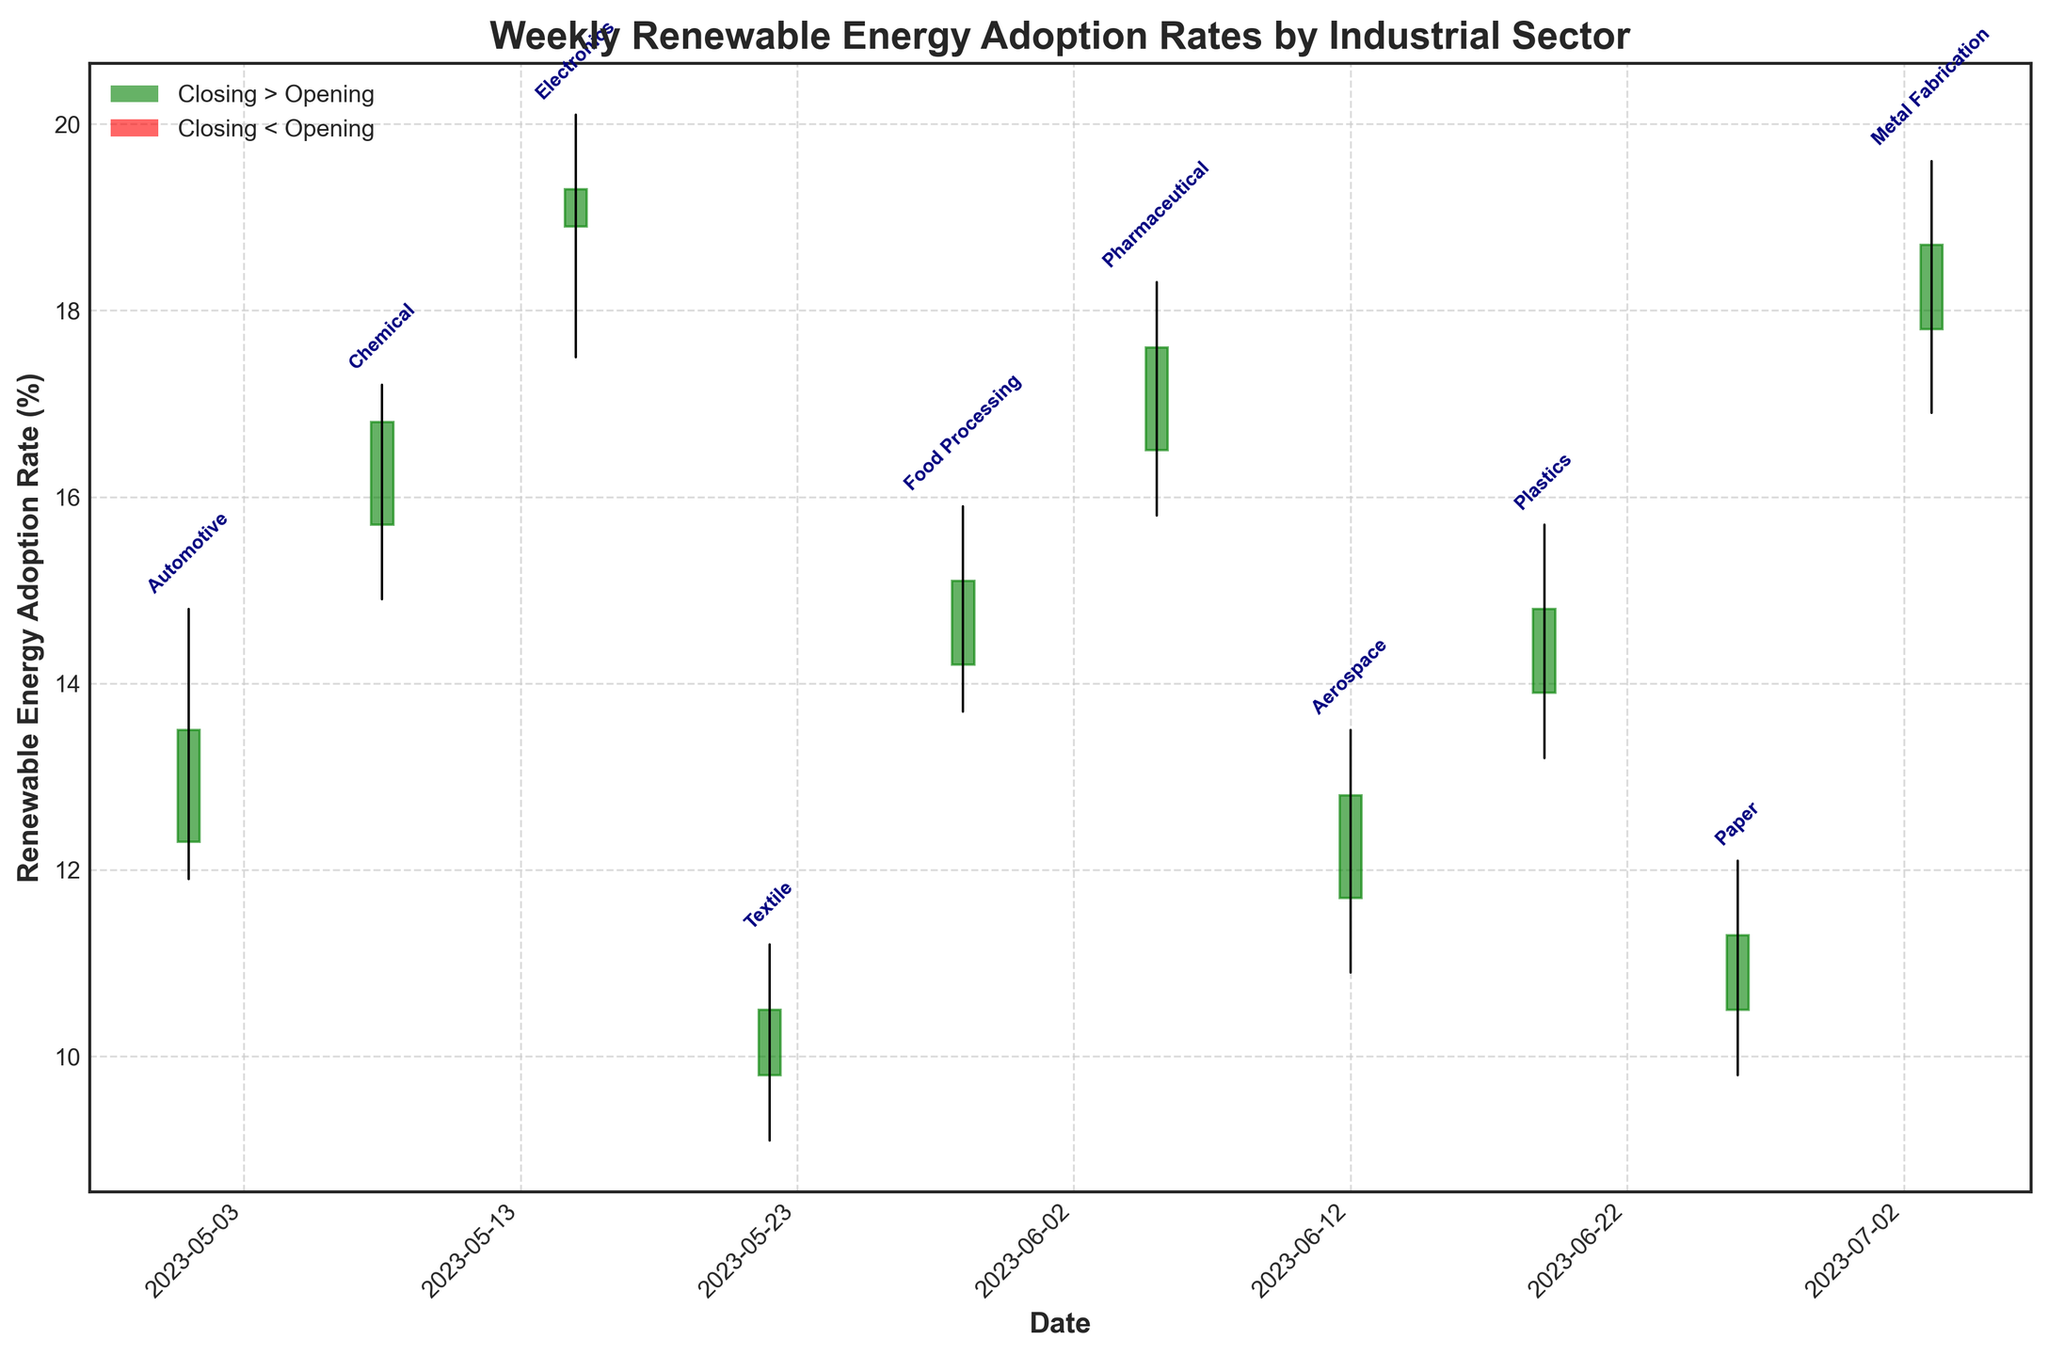What's the title of the figure? The title of the figure is displayed at the top of the plot.
Answer: Weekly Renewable Energy Adoption Rates by Industrial Sector Which sector has the highest closing rate in the given data range? By examining the end points of the rectangles for each sector, the highest closing rate falls on the sector with the highest rectangle end, which is the Electronics sector in the third week (2023-05-15).
Answer: Electronics What color represents a week where the closing rate is higher than the opening rate? The color used for weeks where the closing rate is higher than the opening rate is green.
Answer: Green How did the Chemical sector perform during the week of 2023-05-08? Based on the annotations and bars, the Chemical sector's rectangle starts at 15.7 (open), peaks at 17.2 (high), bottoms at 14.9 (low), and ends at 16.8 (close), with the green color indicating closing higher than opening.
Answer: Green, 15.7 open, 17.2 high, 14.9 low, 16.8 close Which sector had the largest range between its high and low values? Calculate the high-low range for each sector: 
Automotive (14.8-11.9=2.9), Chemical (17.2-14.9=2.3), Electronics (20.1-17.5=2.6), Textile (11.2-9.1=2.1), Food Processing (15.9-13.7=2.2), Pharmaceutical (18.3-15.8=2.5), Aerospace (13.5-10.9=2.6), Plastics (15.7-13.2=2.5), Paper (12.1-9.8=2.3), Metal Fabrication (19.6-16.9=2.7). The Automotive sector has the largest range of 2.9.
Answer: Automotive Which sector had a closing rate lower than its opening rate? This can be identified by looking at red rectangles, which represent those sectors. The Automotive sector has a red rectangle.
Answer: Automotive What was the opening rate for the Paper sector in the last week of June 2023? The Paper sector is annotated at 2023-06-26, and its rectangle starts at 10.5 on the y-axis, indicating this as the opening rate.
Answer: 10.5 Is there a trend of increasing adoption rates in the Aerospace sector over its observed week? The Aerospace sector (week of 2023-06-12) shows no visible trend of increasing adoption rates since it has its closing rate lower than its opening rate (close < open).
Answer: No Which two sectors had nearly the same high value but different outcomes in their closing rates? The sectors with nearly the same high value can be determined by finding close numerical values: Pharmaceutical (18.3) and Metal Fabrication (19.6). Despite having close high values, the closing rate for Metal Fabrication (18.7) is lower than Pharmaceutical (17.6).
Answer: Pharmaceutical and Metal Fabrication What are the key dates where renewable energy adoption showed high market volatility? Market volatility can be assessed from the length of the high-low vertical lines:
  - Automotive (2023-05-01) 
  - Electronics (2023-05-15)
  These weeks show considerable differences between their high and low values, indicating volatility.
Answer: 2023-05-01 and 2023-05-15 